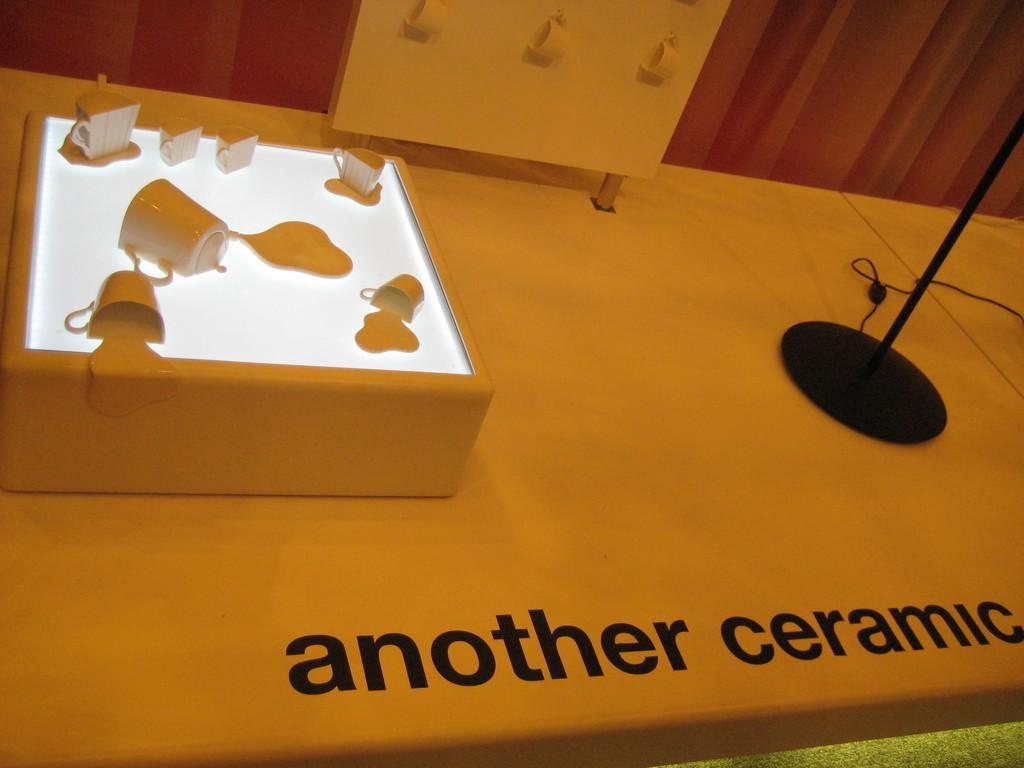<image>
Share a concise interpretation of the image provided. Ceramic mugs are on display as if they are melting into a light surface. 